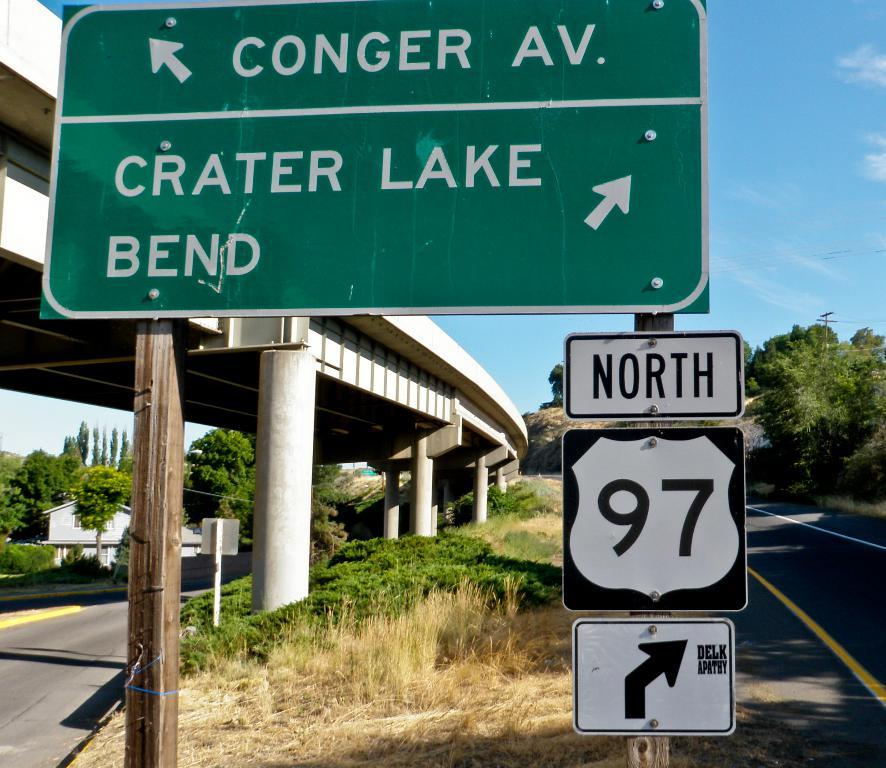<image>
Create a compact narrative representing the image presented. A freeway overpass has a green sign that says Conger Av and Crater Lake Bend. 